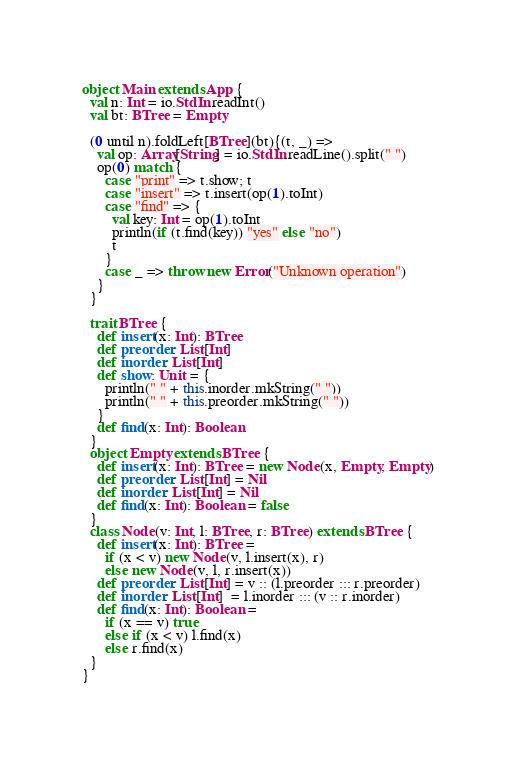<code> <loc_0><loc_0><loc_500><loc_500><_Scala_>object Main extends App {
  val n: Int = io.StdIn.readInt()
  val bt: BTree = Empty

  (0 until n).foldLeft[BTree](bt){(t, _) =>
    val op: Array[String] = io.StdIn.readLine().split(" ")
    op(0) match {
      case "print" => t.show; t
      case "insert" => t.insert(op(1).toInt)
      case "find" => {
        val key: Int = op(1).toInt
        println(if (t.find(key)) "yes" else "no")
        t
      }
      case _ => throw new Error("Unknown operation")
    }
  }

  trait BTree {
    def insert(x: Int): BTree
    def preorder: List[Int]
    def inorder: List[Int]
    def show: Unit = {
      println(" " + this.inorder.mkString(" "))
      println(" " + this.preorder.mkString(" "))
    }
    def find(x: Int): Boolean
  }
  object Empty extends BTree {
    def insert(x: Int): BTree = new Node(x, Empty, Empty)
    def preorder: List[Int] = Nil
    def inorder: List[Int] = Nil
    def find(x: Int): Boolean = false
  }
  class Node(v: Int, l: BTree, r: BTree) extends BTree {
    def insert(x: Int): BTree =
      if (x < v) new Node(v, l.insert(x), r)
      else new Node(v, l, r.insert(x))
    def preorder: List[Int] = v :: (l.preorder ::: r.preorder)
    def inorder: List[Int]  = l.inorder ::: (v :: r.inorder)
    def find(x: Int): Boolean =
      if (x == v) true
      else if (x < v) l.find(x)
      else r.find(x)
  }
}
</code> 